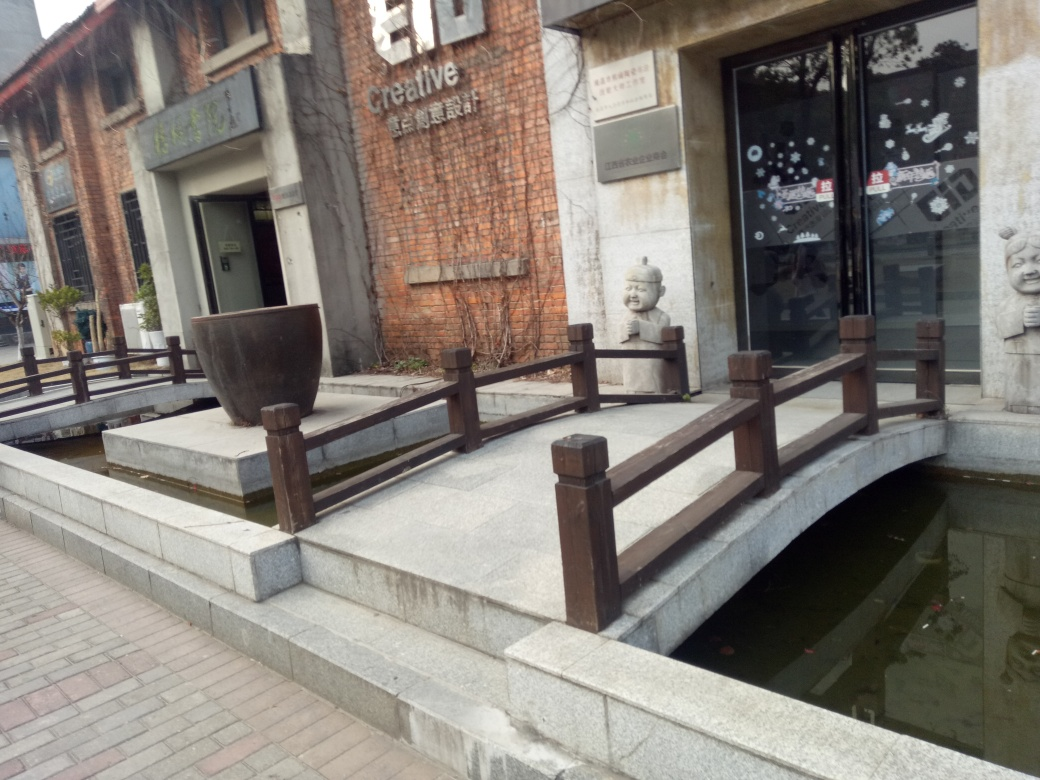What might be the function of the building seen in the picture? Based on the visible signage that reads 'creative,' the artistic designs, and the modern-yet-classic facade, the building is likely used for cultural or artistic purposes. It could house art studios, galleries, or creative workshops. The inviting exterior with the sculptures and the clear presence of art installations suggest a space dedicated to creativity and possibly community engagement with art and design. 